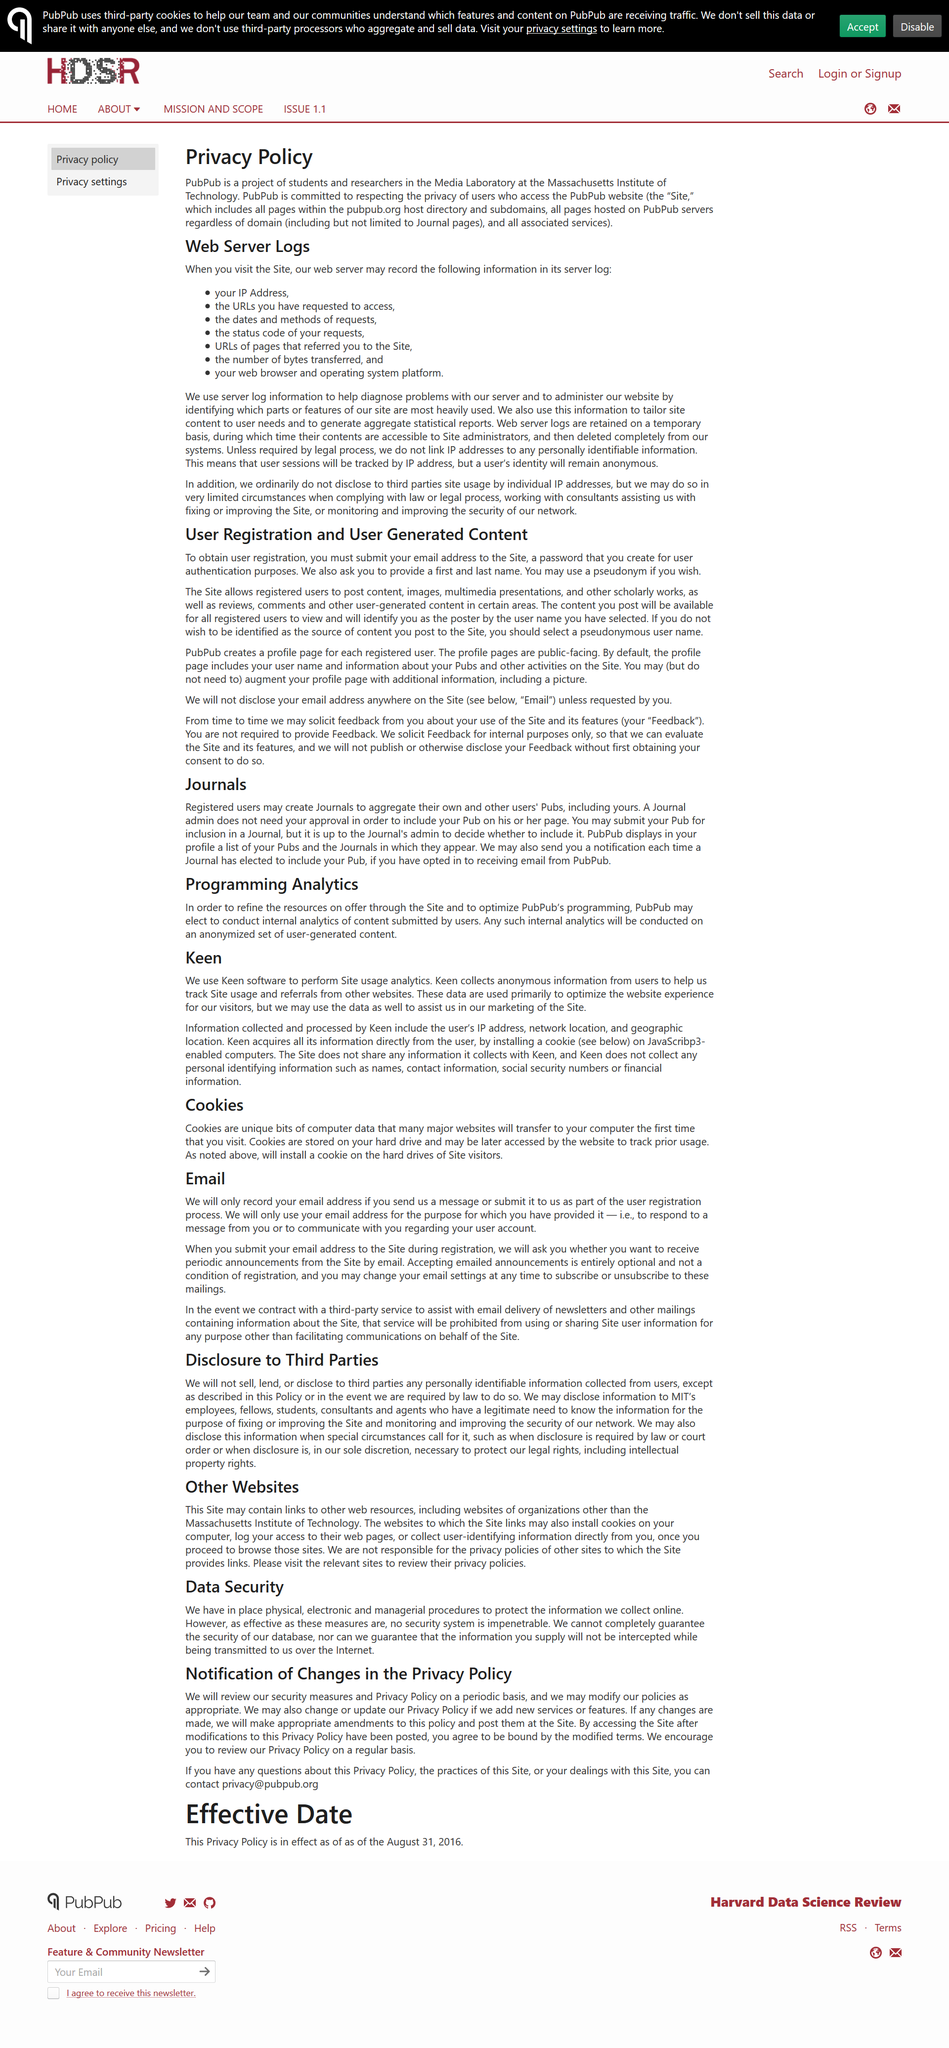Highlight a few significant elements in this photo. Yes, PubPub uses internal analytics. Yes, a pseudonym can be used. It is our commitment not to sell, lend, or disclose to third parties any personal data. It is not necessary for a Journal admin to obtain approval from the author before including the author's Pub on the Journal admin's page. There are three types of procedures used to protect data: physical, electronic, and managerial. 